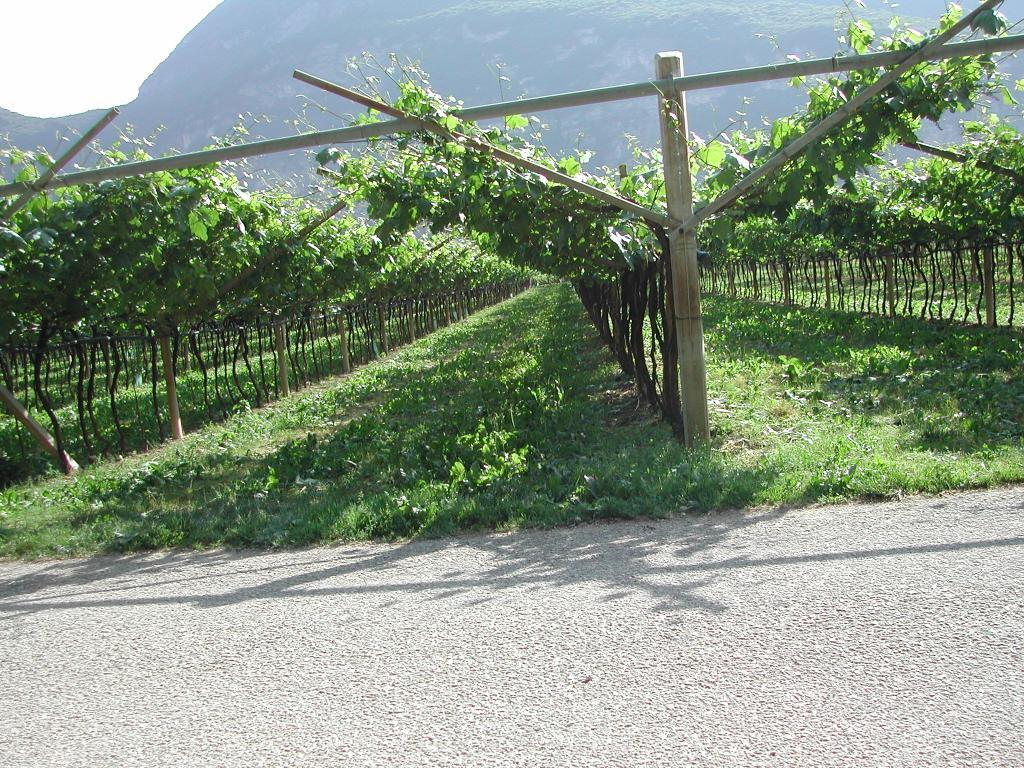What is located at the bottom of the image? There is a road at the bottom of the image. What can be seen in the middle of the image? There are trees in the middle of the image. What is visible in the background of the image? There is a mountain in the background of the image. How does the road fold in the image? The road does not fold in the image; it is a straight path at the bottom of the image. What level of difficulty is the mountain on in the image? The image does not provide information about the difficulty level of the mountain. 